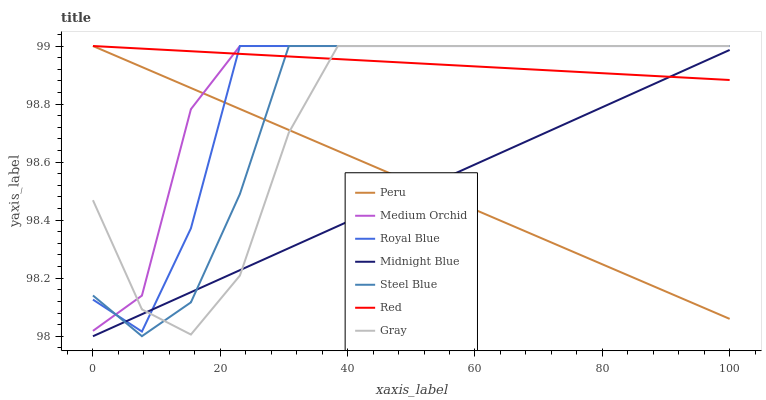Does Medium Orchid have the minimum area under the curve?
Answer yes or no. No. Does Medium Orchid have the maximum area under the curve?
Answer yes or no. No. Is Midnight Blue the smoothest?
Answer yes or no. No. Is Midnight Blue the roughest?
Answer yes or no. No. Does Medium Orchid have the lowest value?
Answer yes or no. No. Does Midnight Blue have the highest value?
Answer yes or no. No. Is Midnight Blue less than Medium Orchid?
Answer yes or no. Yes. Is Medium Orchid greater than Midnight Blue?
Answer yes or no. Yes. Does Midnight Blue intersect Medium Orchid?
Answer yes or no. No. 